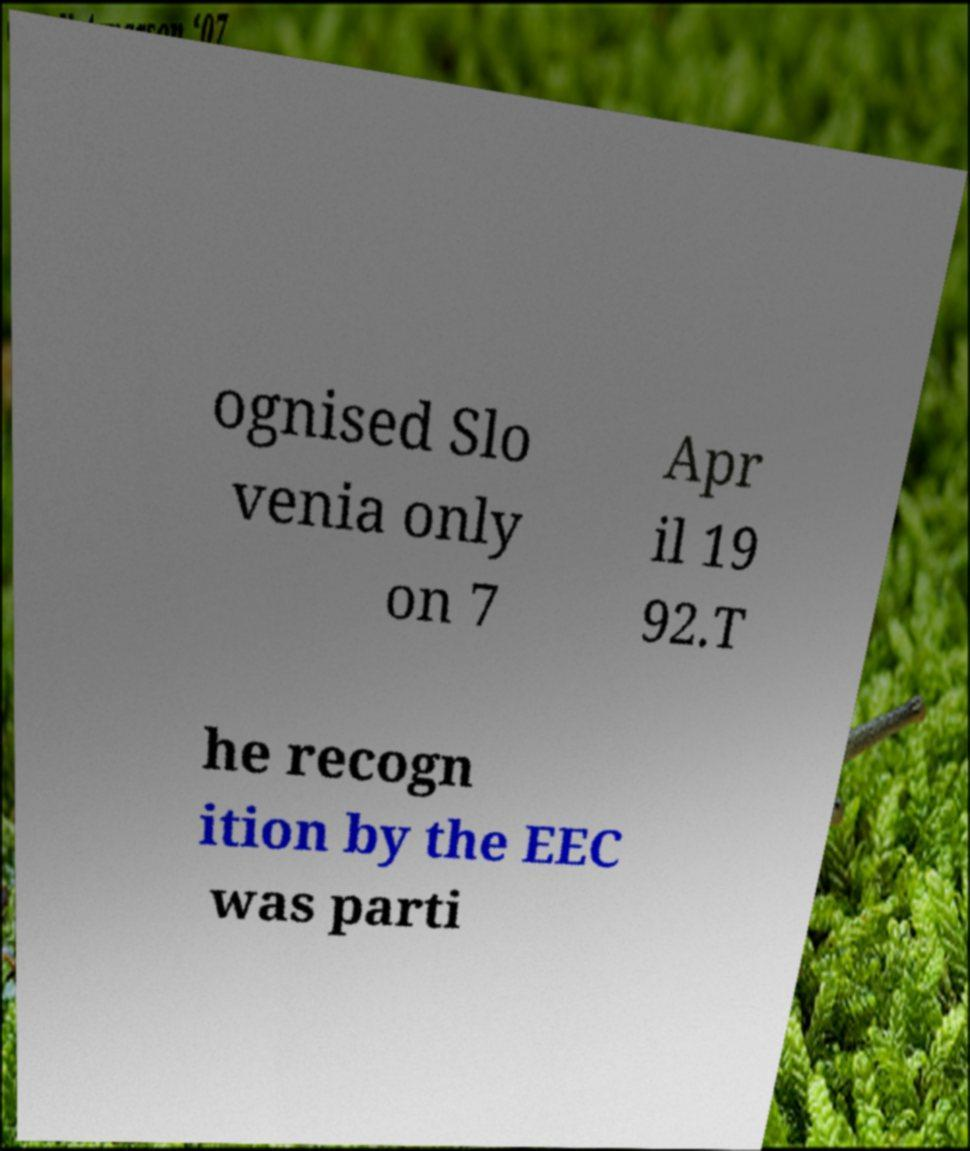Can you read and provide the text displayed in the image?This photo seems to have some interesting text. Can you extract and type it out for me? ognised Slo venia only on 7 Apr il 19 92.T he recogn ition by the EEC was parti 